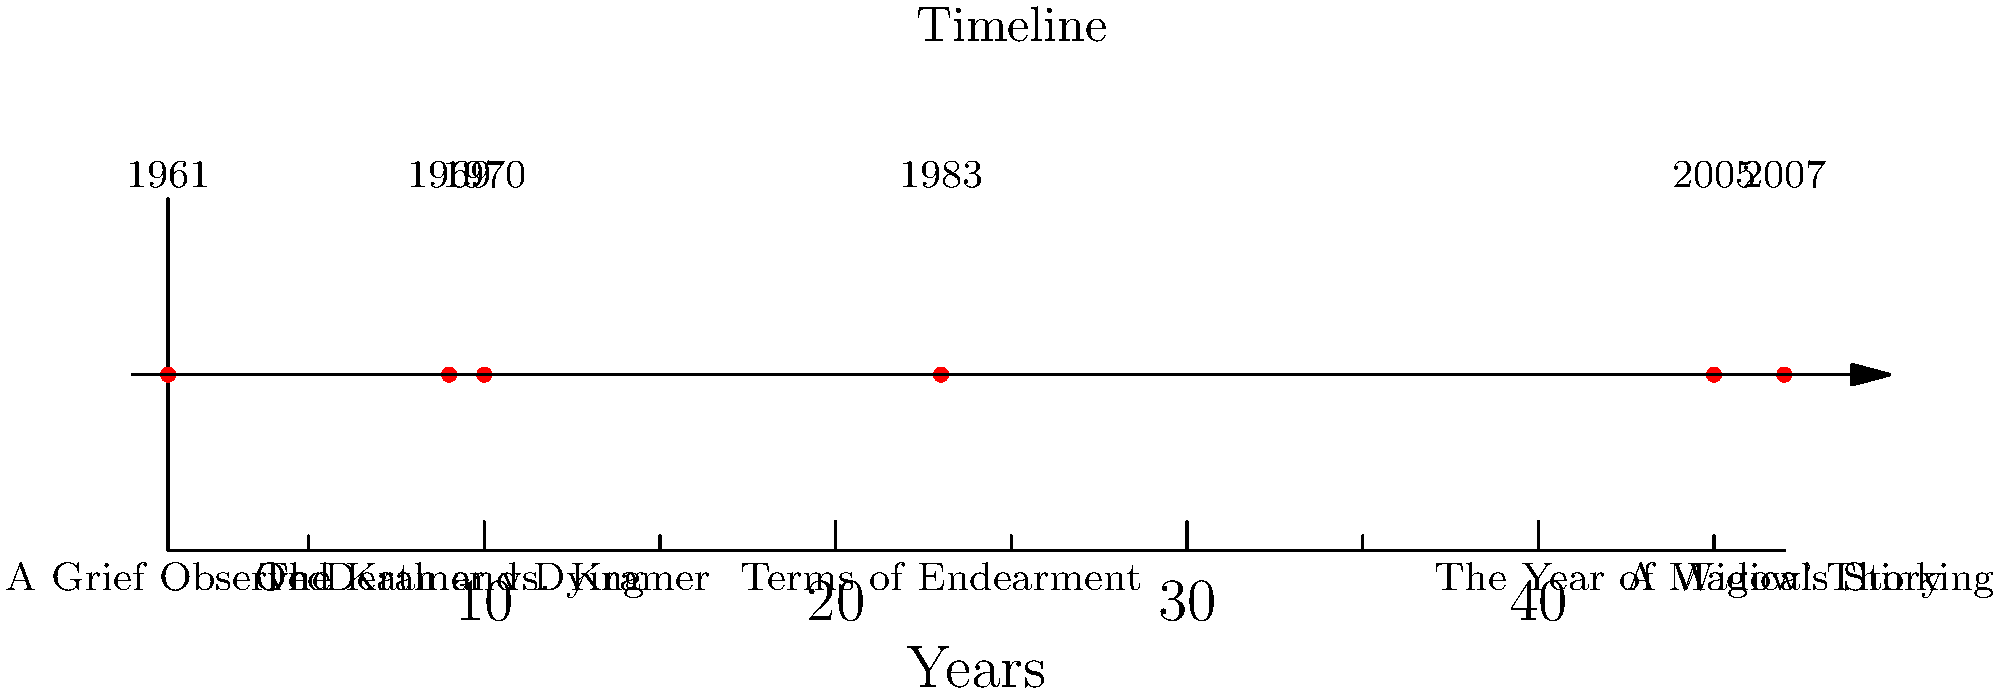Analyze the timeline of influential works on grief and loss in literature. Which book, published in 1969, revolutionized our understanding of death and dying and introduced the five stages of grief? To answer this question, we need to examine the timeline carefully:

1. The timeline shows six influential works on grief and loss in literature from 1961 to 2007.

2. We're looking for a book published in 1969.

3. Scanning the timeline, we see that "On Death and Dying" was published in 1969.

4. "On Death and Dying" by Elisabeth Kübler-Ross is indeed a groundbreaking work that introduced the five stages of grief (denial, anger, bargaining, depression, and acceptance).

5. This book revolutionized our understanding of death and dying by providing a framework for understanding the psychological processes that people go through when facing death or experiencing loss.

6. No other book on the timeline matches the year 1969 or is known for introducing the five stages of grief.

Therefore, "On Death and Dying" is the correct answer to this question.
Answer: On Death and Dying 